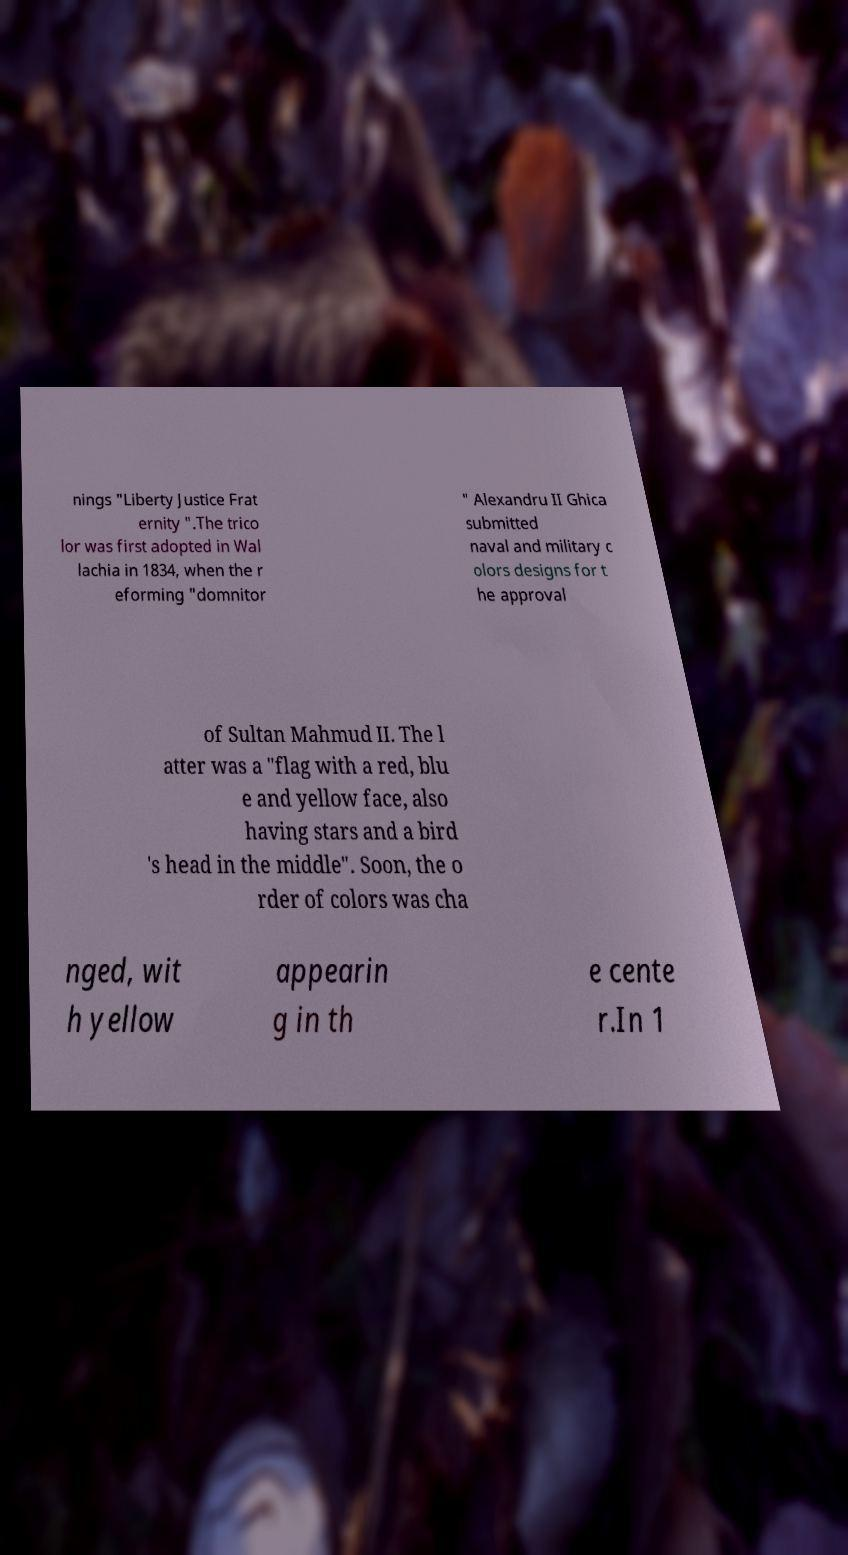There's text embedded in this image that I need extracted. Can you transcribe it verbatim? nings "Liberty Justice Frat ernity ".The trico lor was first adopted in Wal lachia in 1834, when the r eforming "domnitor " Alexandru II Ghica submitted naval and military c olors designs for t he approval of Sultan Mahmud II. The l atter was a "flag with a red, blu e and yellow face, also having stars and a bird 's head in the middle". Soon, the o rder of colors was cha nged, wit h yellow appearin g in th e cente r.In 1 